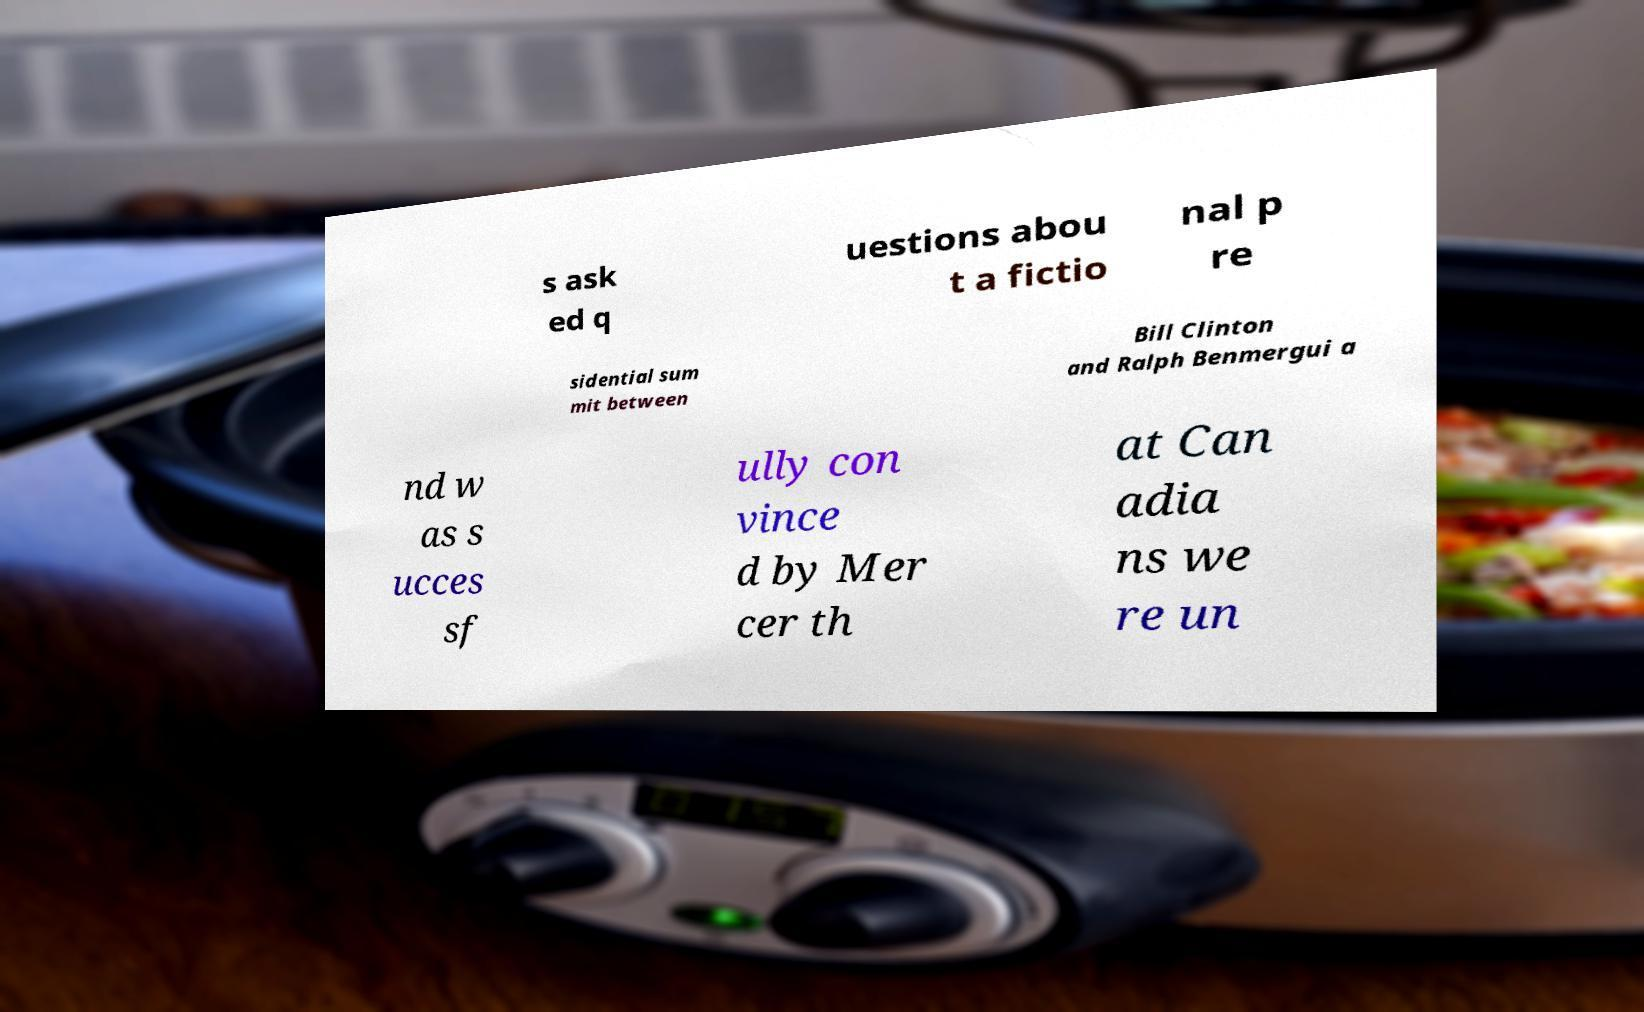I need the written content from this picture converted into text. Can you do that? s ask ed q uestions abou t a fictio nal p re sidential sum mit between Bill Clinton and Ralph Benmergui a nd w as s ucces sf ully con vince d by Mer cer th at Can adia ns we re un 